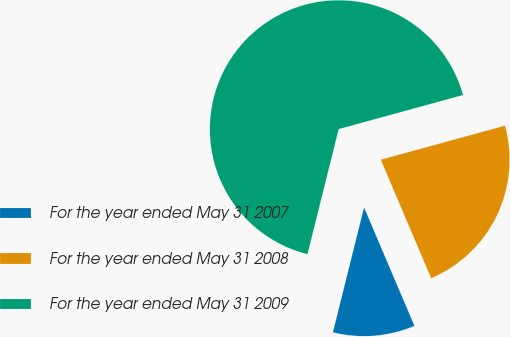Convert chart to OTSL. <chart><loc_0><loc_0><loc_500><loc_500><pie_chart><fcel>For the year ended May 31 2007<fcel>For the year ended May 31 2008<fcel>For the year ended May 31 2009<nl><fcel>10.29%<fcel>22.86%<fcel>66.86%<nl></chart> 